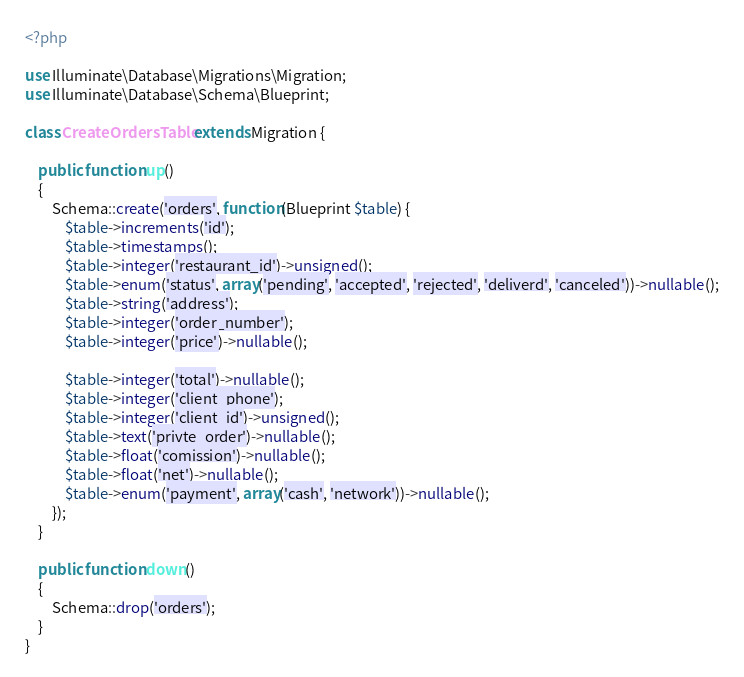<code> <loc_0><loc_0><loc_500><loc_500><_PHP_><?php

use Illuminate\Database\Migrations\Migration;
use Illuminate\Database\Schema\Blueprint;

class CreateOrdersTable extends Migration {

	public function up()
	{
		Schema::create('orders', function(Blueprint $table) {
			$table->increments('id');
			$table->timestamps();
			$table->integer('restaurant_id')->unsigned();
			$table->enum('status', array('pending', 'accepted', 'rejected', 'deliverd', 'canceled'))->nullable();
			$table->string('address');
			$table->integer('order_number');
			$table->integer('price')->nullable();

			$table->integer('total')->nullable();
			$table->integer('client_phone');
			$table->integer('client_id')->unsigned();
			$table->text('privte_order')->nullable();
			$table->float('comission')->nullable();
			$table->float('net')->nullable();
			$table->enum('payment', array('cash', 'network'))->nullable();
		});
	}

	public function down()
	{
		Schema::drop('orders');
	}
}</code> 